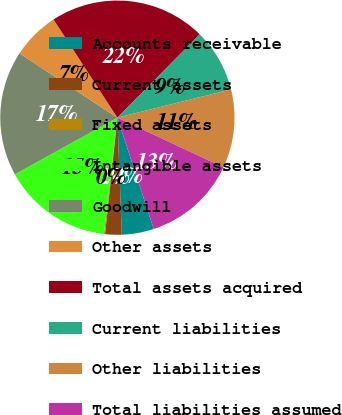Convert chart to OTSL. <chart><loc_0><loc_0><loc_500><loc_500><pie_chart><fcel>Accounts receivable<fcel>Current assets<fcel>Fixed assets<fcel>Intangible assets<fcel>Goodwill<fcel>Other assets<fcel>Total assets acquired<fcel>Current liabilities<fcel>Other liabilities<fcel>Total liabilities assumed<nl><fcel>4.43%<fcel>2.28%<fcel>0.14%<fcel>15.14%<fcel>17.29%<fcel>6.57%<fcel>21.58%<fcel>8.71%<fcel>10.86%<fcel>13.0%<nl></chart> 